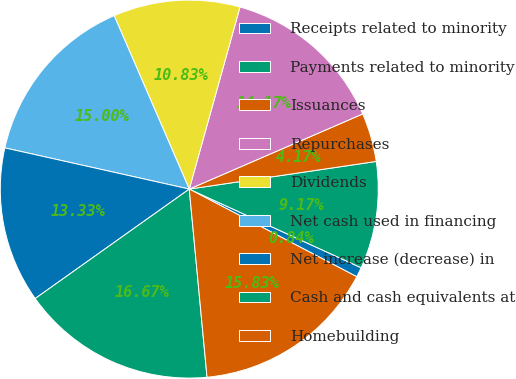<chart> <loc_0><loc_0><loc_500><loc_500><pie_chart><fcel>Receipts related to minority<fcel>Payments related to minority<fcel>Issuances<fcel>Repurchases<fcel>Dividends<fcel>Net cash used in financing<fcel>Net increase (decrease) in<fcel>Cash and cash equivalents at<fcel>Homebuilding<nl><fcel>0.84%<fcel>9.17%<fcel>4.17%<fcel>14.17%<fcel>10.83%<fcel>15.0%<fcel>13.33%<fcel>16.67%<fcel>15.83%<nl></chart> 